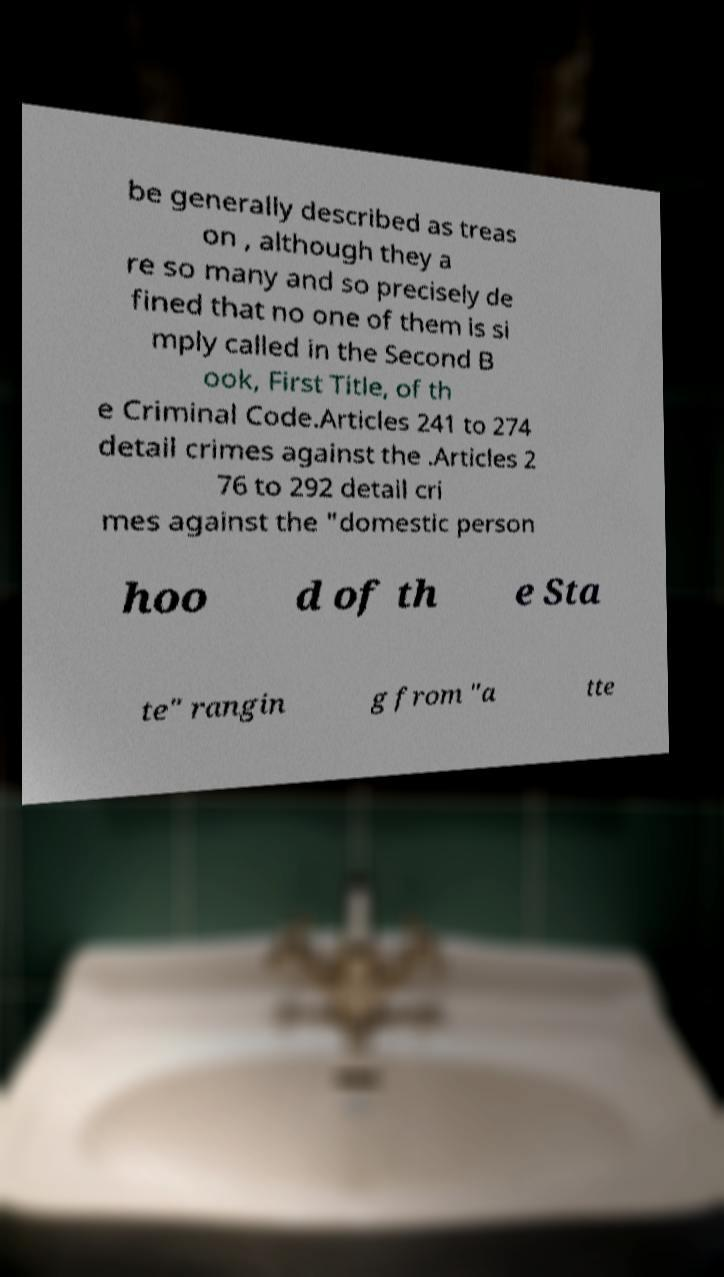For documentation purposes, I need the text within this image transcribed. Could you provide that? be generally described as treas on , although they a re so many and so precisely de fined that no one of them is si mply called in the Second B ook, First Title, of th e Criminal Code.Articles 241 to 274 detail crimes against the .Articles 2 76 to 292 detail cri mes against the "domestic person hoo d of th e Sta te" rangin g from "a tte 